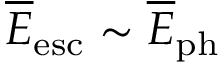Convert formula to latex. <formula><loc_0><loc_0><loc_500><loc_500>\overline { E } _ { e s c } \sim \overline { E } _ { p h }</formula> 